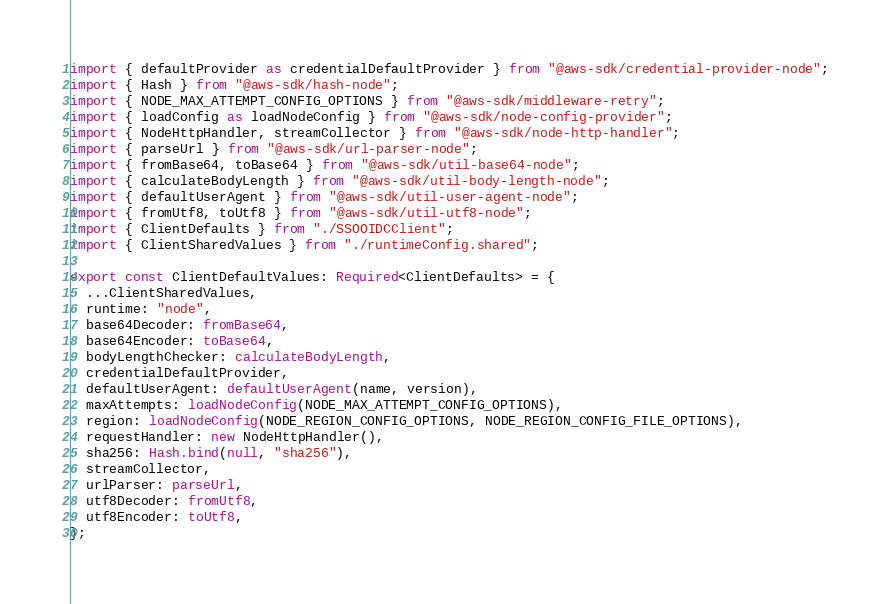Convert code to text. <code><loc_0><loc_0><loc_500><loc_500><_TypeScript_>import { defaultProvider as credentialDefaultProvider } from "@aws-sdk/credential-provider-node";
import { Hash } from "@aws-sdk/hash-node";
import { NODE_MAX_ATTEMPT_CONFIG_OPTIONS } from "@aws-sdk/middleware-retry";
import { loadConfig as loadNodeConfig } from "@aws-sdk/node-config-provider";
import { NodeHttpHandler, streamCollector } from "@aws-sdk/node-http-handler";
import { parseUrl } from "@aws-sdk/url-parser-node";
import { fromBase64, toBase64 } from "@aws-sdk/util-base64-node";
import { calculateBodyLength } from "@aws-sdk/util-body-length-node";
import { defaultUserAgent } from "@aws-sdk/util-user-agent-node";
import { fromUtf8, toUtf8 } from "@aws-sdk/util-utf8-node";
import { ClientDefaults } from "./SSOOIDCClient";
import { ClientSharedValues } from "./runtimeConfig.shared";

export const ClientDefaultValues: Required<ClientDefaults> = {
  ...ClientSharedValues,
  runtime: "node",
  base64Decoder: fromBase64,
  base64Encoder: toBase64,
  bodyLengthChecker: calculateBodyLength,
  credentialDefaultProvider,
  defaultUserAgent: defaultUserAgent(name, version),
  maxAttempts: loadNodeConfig(NODE_MAX_ATTEMPT_CONFIG_OPTIONS),
  region: loadNodeConfig(NODE_REGION_CONFIG_OPTIONS, NODE_REGION_CONFIG_FILE_OPTIONS),
  requestHandler: new NodeHttpHandler(),
  sha256: Hash.bind(null, "sha256"),
  streamCollector,
  urlParser: parseUrl,
  utf8Decoder: fromUtf8,
  utf8Encoder: toUtf8,
};
</code> 